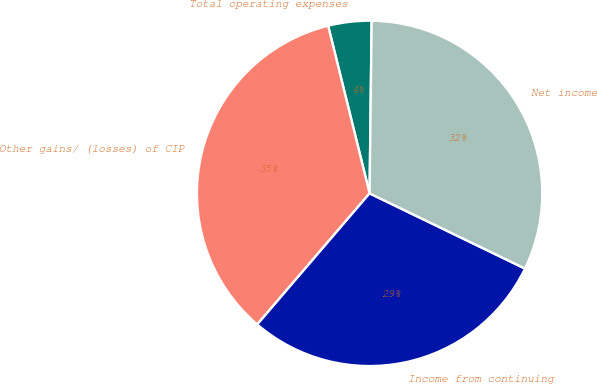<chart> <loc_0><loc_0><loc_500><loc_500><pie_chart><fcel>Total operating expenses<fcel>Other gains/ (losses) of CIP<fcel>Income from continuing<fcel>Net income<nl><fcel>4.05%<fcel>34.86%<fcel>29.1%<fcel>31.98%<nl></chart> 